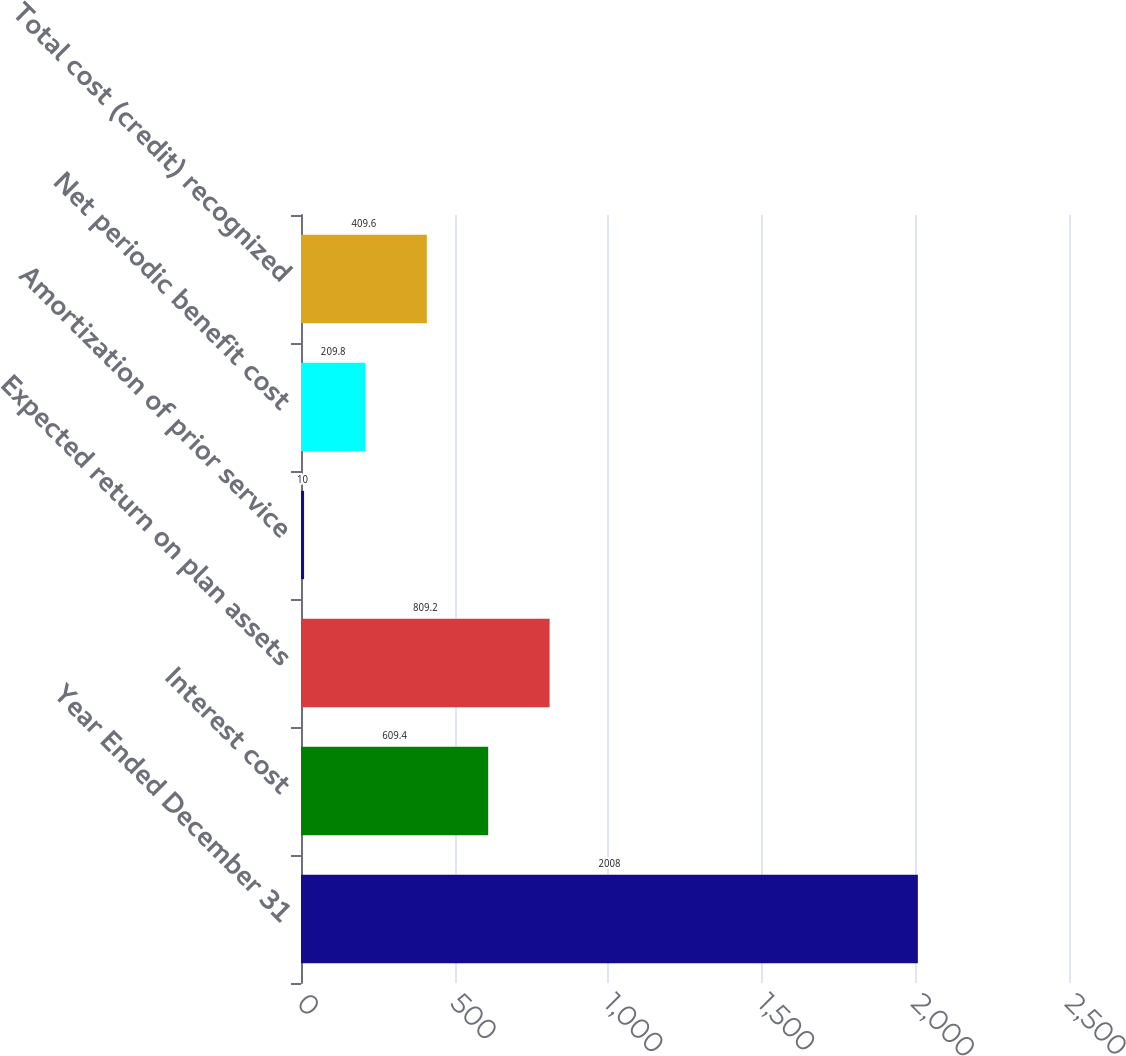Convert chart to OTSL. <chart><loc_0><loc_0><loc_500><loc_500><bar_chart><fcel>Year Ended December 31<fcel>Interest cost<fcel>Expected return on plan assets<fcel>Amortization of prior service<fcel>Net periodic benefit cost<fcel>Total cost (credit) recognized<nl><fcel>2008<fcel>609.4<fcel>809.2<fcel>10<fcel>209.8<fcel>409.6<nl></chart> 